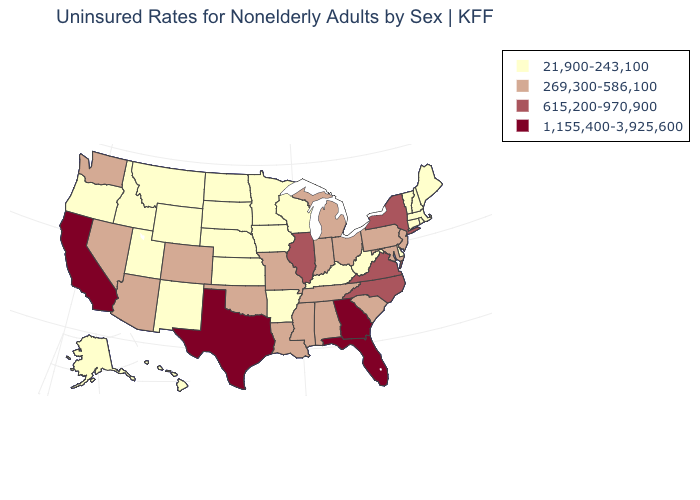Does West Virginia have the same value as Arkansas?
Write a very short answer. Yes. Does the map have missing data?
Short answer required. No. Name the states that have a value in the range 269,300-586,100?
Write a very short answer. Alabama, Arizona, Colorado, Indiana, Louisiana, Maryland, Michigan, Mississippi, Missouri, Nevada, New Jersey, Ohio, Oklahoma, Pennsylvania, South Carolina, Tennessee, Washington. Does Illinois have the highest value in the MidWest?
Give a very brief answer. Yes. Name the states that have a value in the range 615,200-970,900?
Answer briefly. Illinois, New York, North Carolina, Virginia. Does Ohio have a lower value than North Carolina?
Quick response, please. Yes. What is the value of Maine?
Give a very brief answer. 21,900-243,100. Name the states that have a value in the range 1,155,400-3,925,600?
Keep it brief. California, Florida, Georgia, Texas. Name the states that have a value in the range 269,300-586,100?
Be succinct. Alabama, Arizona, Colorado, Indiana, Louisiana, Maryland, Michigan, Mississippi, Missouri, Nevada, New Jersey, Ohio, Oklahoma, Pennsylvania, South Carolina, Tennessee, Washington. Name the states that have a value in the range 615,200-970,900?
Keep it brief. Illinois, New York, North Carolina, Virginia. What is the value of Rhode Island?
Answer briefly. 21,900-243,100. Does Illinois have the highest value in the MidWest?
Answer briefly. Yes. Which states hav the highest value in the Northeast?
Answer briefly. New York. Name the states that have a value in the range 1,155,400-3,925,600?
Give a very brief answer. California, Florida, Georgia, Texas. What is the lowest value in states that border North Carolina?
Concise answer only. 269,300-586,100. 